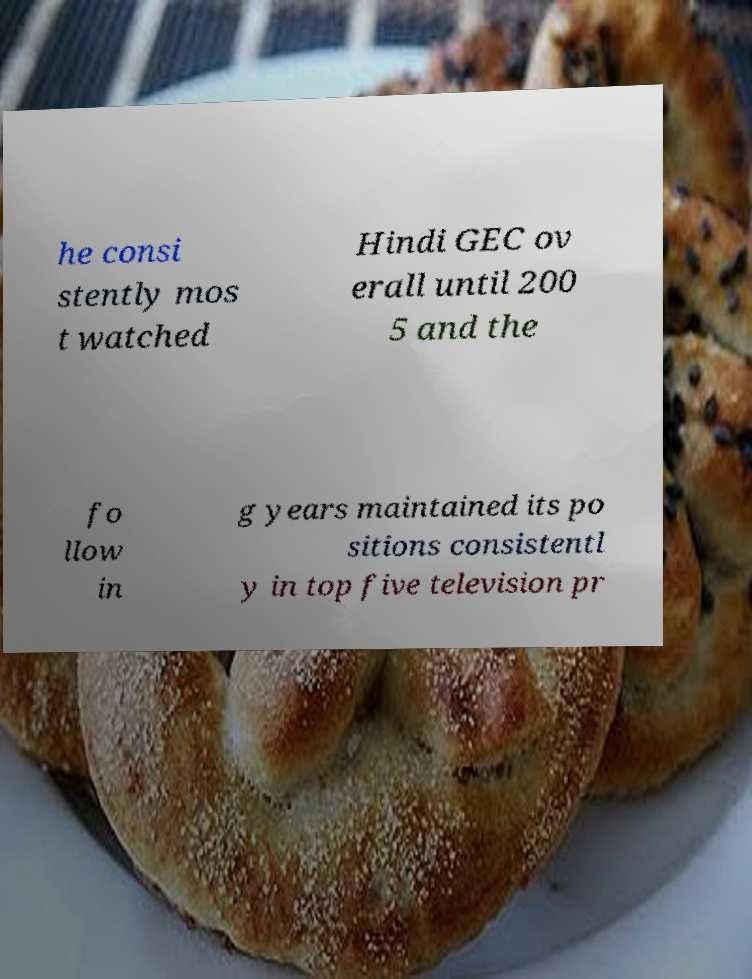Can you read and provide the text displayed in the image?This photo seems to have some interesting text. Can you extract and type it out for me? he consi stently mos t watched Hindi GEC ov erall until 200 5 and the fo llow in g years maintained its po sitions consistentl y in top five television pr 